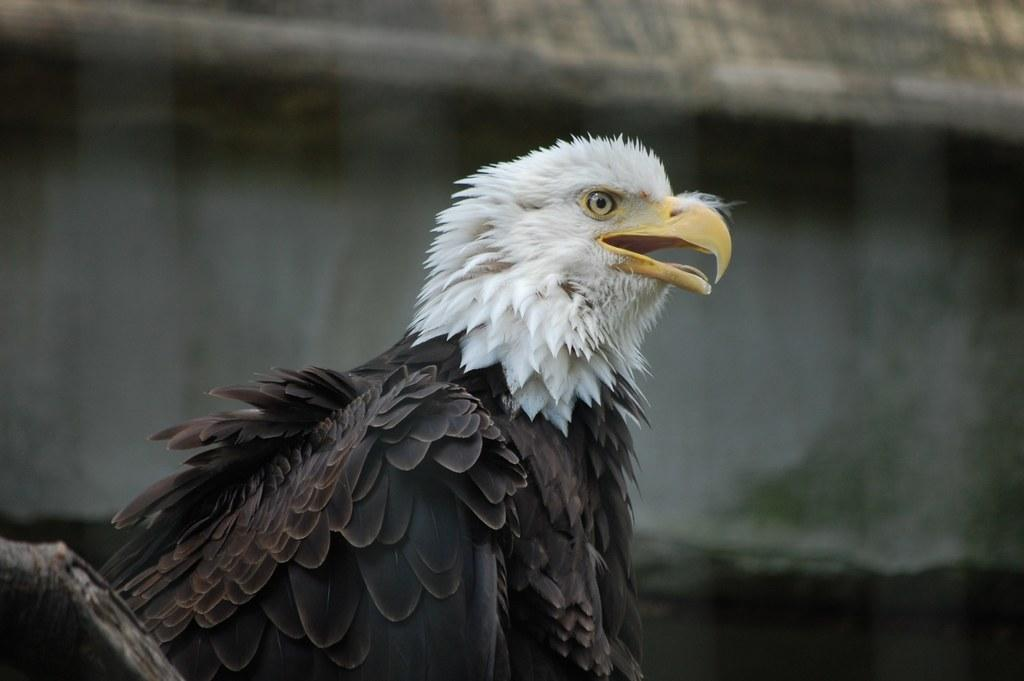What type of bird is in the image? There is an eagle in the image. Can you describe the eagle's appearance? The eagle has white and brown feathers and a yellow beak. What is the background of the image like? The background of the image appears blurry. What type of art is being created at the plantation in the image? There is no art or plantation present in the image; it features an eagle with a blurry background. 